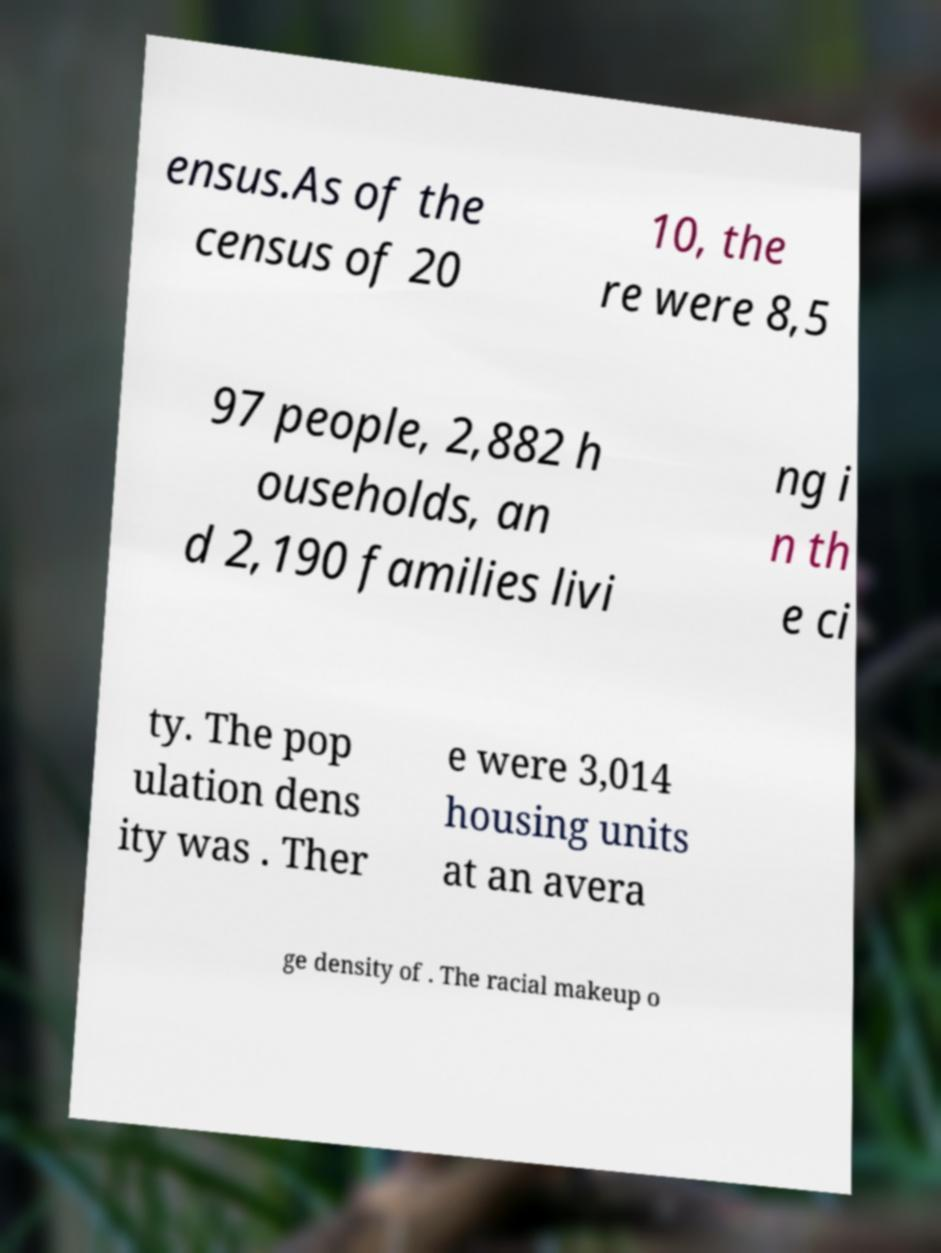Can you read and provide the text displayed in the image?This photo seems to have some interesting text. Can you extract and type it out for me? ensus.As of the census of 20 10, the re were 8,5 97 people, 2,882 h ouseholds, an d 2,190 families livi ng i n th e ci ty. The pop ulation dens ity was . Ther e were 3,014 housing units at an avera ge density of . The racial makeup o 